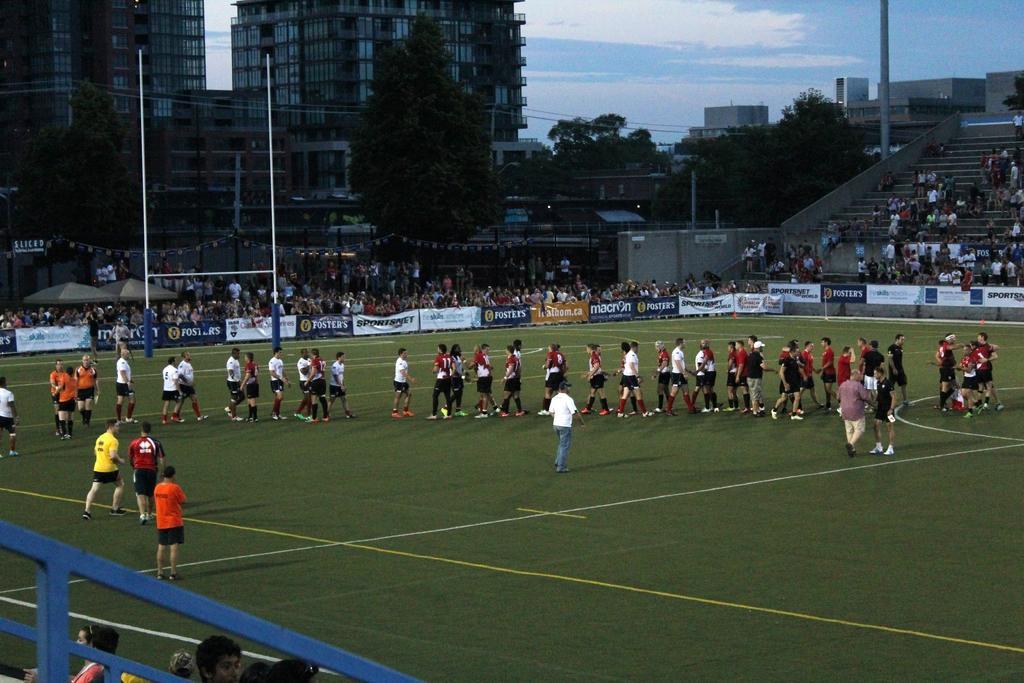Can you describe this image briefly? In this picture we can see few people are standing in ground. And few people are sitting here. And these are the hoarding and this is the pole. Here we can see many trees. These are the buildings. And in the background there is a sky with the clouds. 